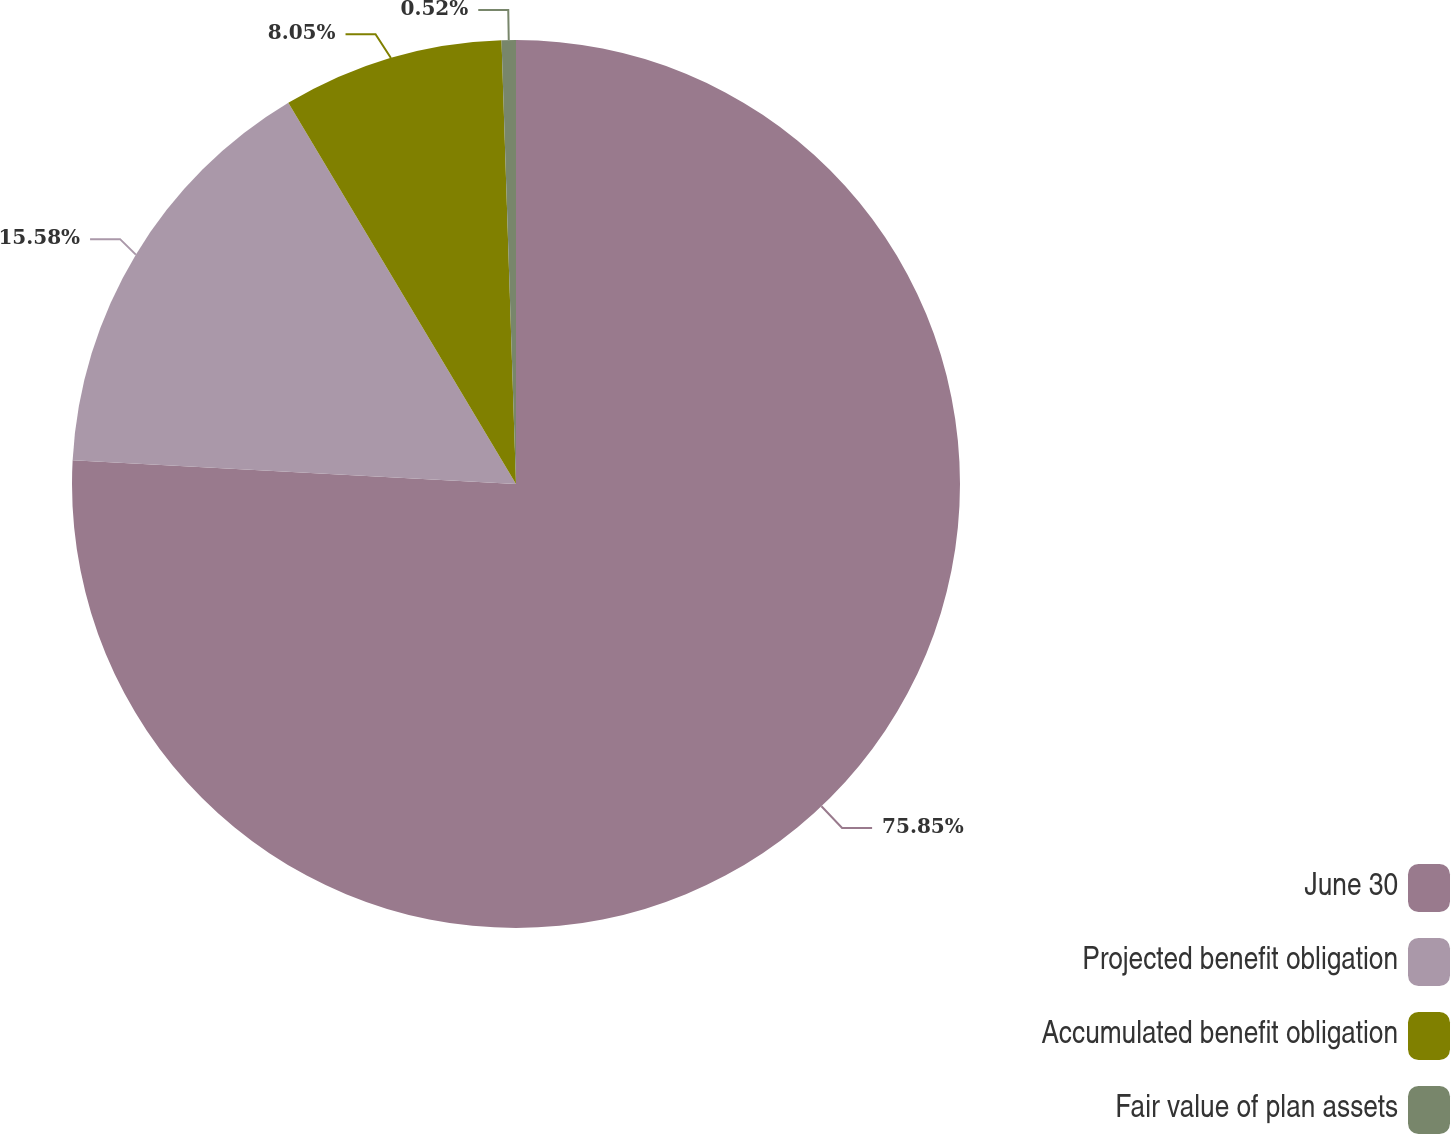Convert chart. <chart><loc_0><loc_0><loc_500><loc_500><pie_chart><fcel>June 30<fcel>Projected benefit obligation<fcel>Accumulated benefit obligation<fcel>Fair value of plan assets<nl><fcel>75.85%<fcel>15.58%<fcel>8.05%<fcel>0.52%<nl></chart> 